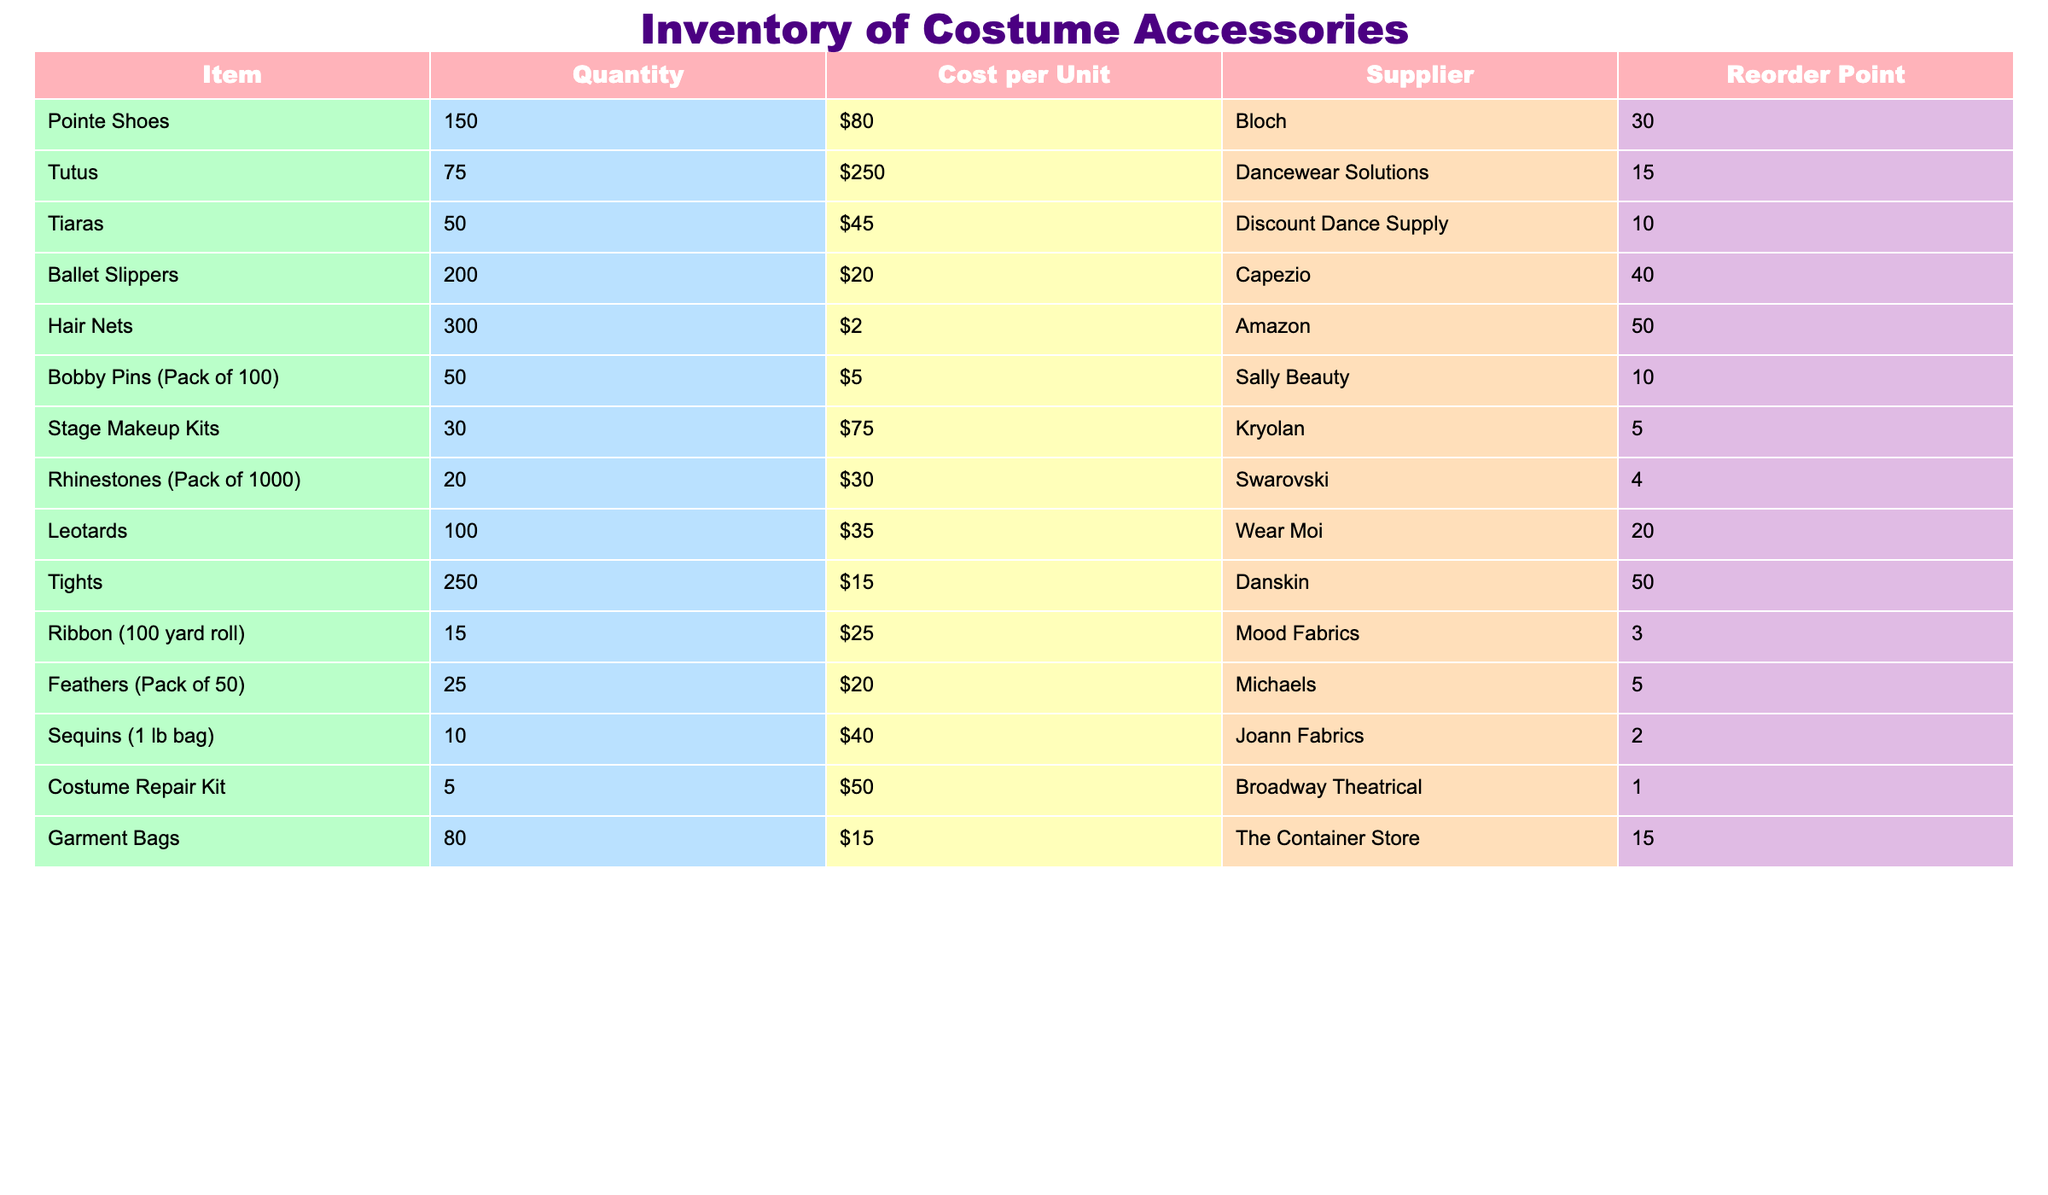What is the total quantity of Tiaras in the inventory? The table shows that there are 50 Tiaras listed under the "Quantity" column.
Answer: 50 Which item has the highest cost per unit, and what is that cost? Referring to the "Cost per Unit" column, the item with the highest cost is Tutus at $250.
Answer: Tutus; $250 Is there a reorder point for Stage Makeup Kits? The table lists a reorder point for Stage Makeup Kits as 5. This means it is necessary to reorder when inventory reaches this level.
Answer: Yes How many more Ballet Slippers are there than Tiaras? The table shows 200 Ballet Slippers and 50 Tiaras. The difference is calculated as 200 - 50 = 150.
Answer: 150 What is the average cost per unit of all items listed? First, sum the cost per unit for each item: ($80 + $250 + $45 + $20 + $2 + $5 + $75 + $30 + $35 + $15 + $25 + $20 + $40 + $50 + $15) = $675. There are 15 items, so the average cost is $675 / 15 = $45.
Answer: $45 Which item has the lowest quantity and what is its reorder point? The table indicates that the Costume Repair Kit has the lowest quantity of 5 and a reorder point of 1.
Answer: Costume Repair Kit; 1 If we combine the quantities of Feathers and Rhinestones, how many total items do we have? The quantity of Feathers is 25, and Rhinestones is 20. Adding these gives 25 + 20 = 45.
Answer: 45 Are there more than 100 items of Tights in the inventory? The table indicates that there are 250 Tights, which is more than 100.
Answer: Yes What is the total cost of all the Pointe Shoes available? The unit cost of Pointe Shoes is $80, and there are 150 units. Therefore, the total cost is calculated as $80 * 150 = $12,000.
Answer: $12,000 How many items in the inventory have a reorder point of 10 or higher? The items with a reorder point of 10 or higher are Pointe Shoes, Tutus, Ballet Slippers, Hair Nets, Bobby Pins, Tights, Garment Bags, totaling 7 items.
Answer: 7 